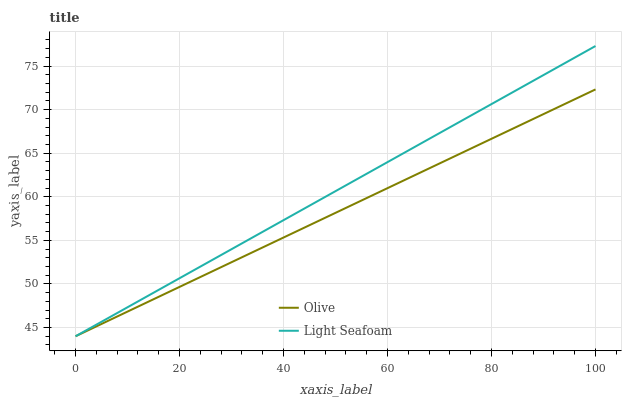Does Olive have the minimum area under the curve?
Answer yes or no. Yes. Does Light Seafoam have the maximum area under the curve?
Answer yes or no. Yes. Does Light Seafoam have the minimum area under the curve?
Answer yes or no. No. Is Olive the smoothest?
Answer yes or no. Yes. Is Light Seafoam the roughest?
Answer yes or no. Yes. Is Light Seafoam the smoothest?
Answer yes or no. No. Does Olive have the lowest value?
Answer yes or no. Yes. Does Light Seafoam have the highest value?
Answer yes or no. Yes. Does Olive intersect Light Seafoam?
Answer yes or no. Yes. Is Olive less than Light Seafoam?
Answer yes or no. No. Is Olive greater than Light Seafoam?
Answer yes or no. No. 